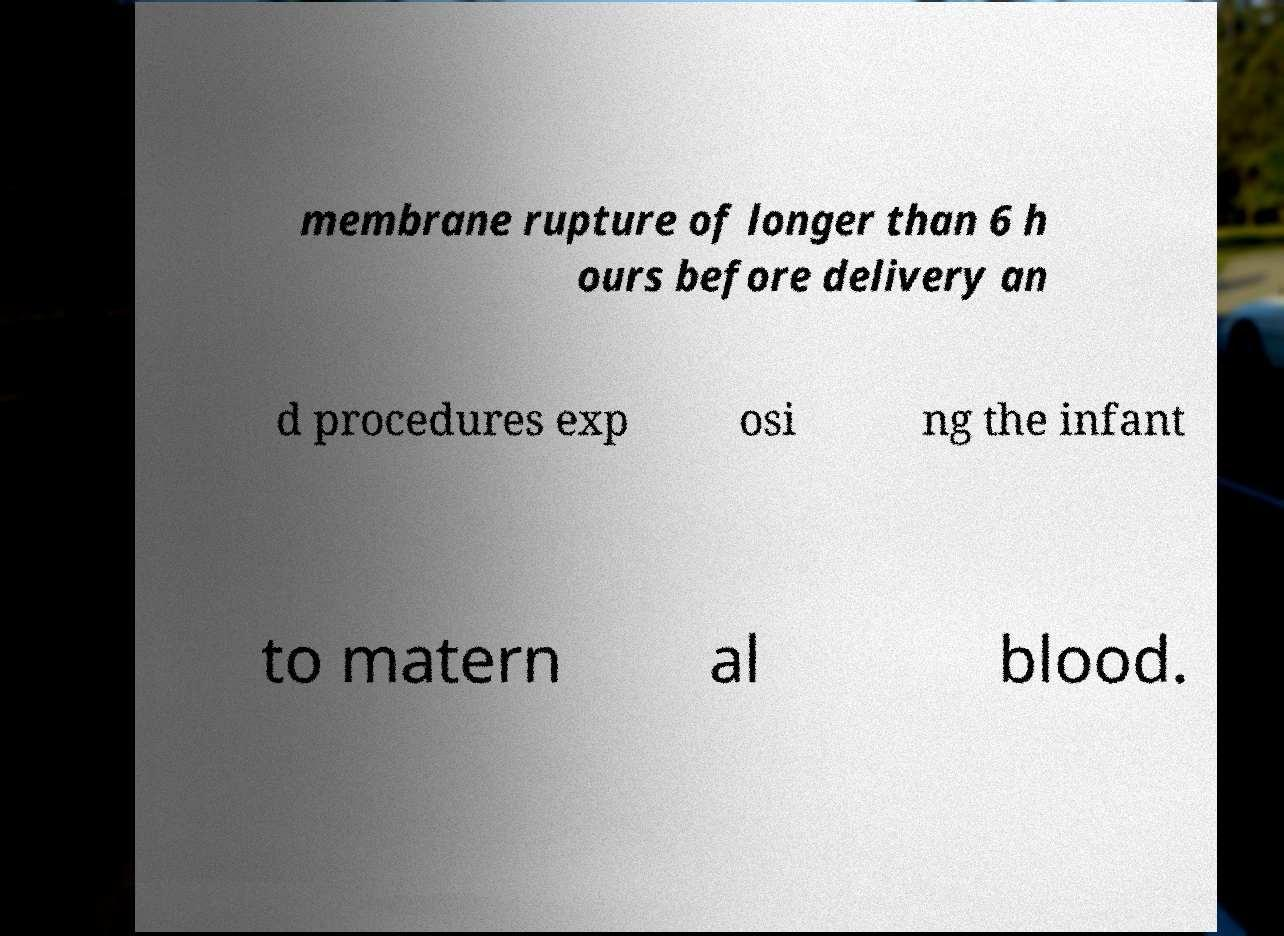Could you extract and type out the text from this image? membrane rupture of longer than 6 h ours before delivery an d procedures exp osi ng the infant to matern al blood. 